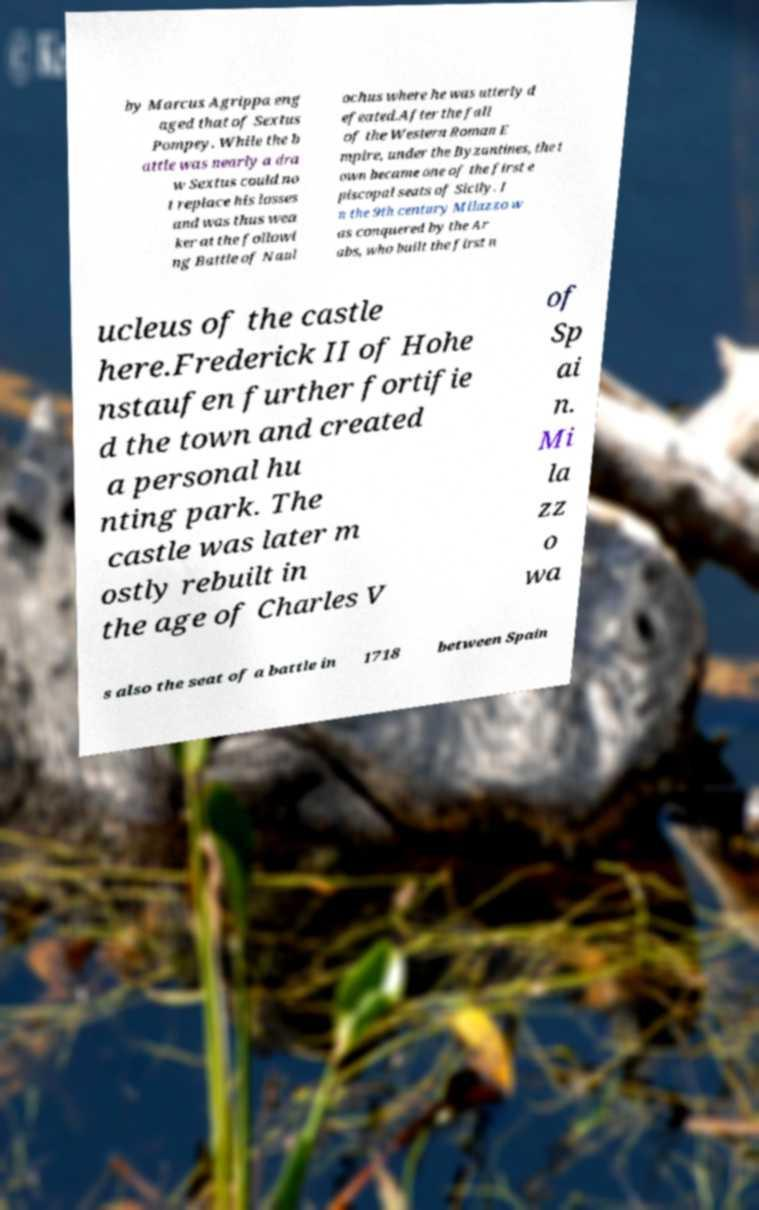There's text embedded in this image that I need extracted. Can you transcribe it verbatim? by Marcus Agrippa eng aged that of Sextus Pompey. While the b attle was nearly a dra w Sextus could no t replace his losses and was thus wea ker at the followi ng Battle of Naul ochus where he was utterly d efeated.After the fall of the Western Roman E mpire, under the Byzantines, the t own became one of the first e piscopal seats of Sicily. I n the 9th century Milazzo w as conquered by the Ar abs, who built the first n ucleus of the castle here.Frederick II of Hohe nstaufen further fortifie d the town and created a personal hu nting park. The castle was later m ostly rebuilt in the age of Charles V of Sp ai n. Mi la zz o wa s also the seat of a battle in 1718 between Spain 